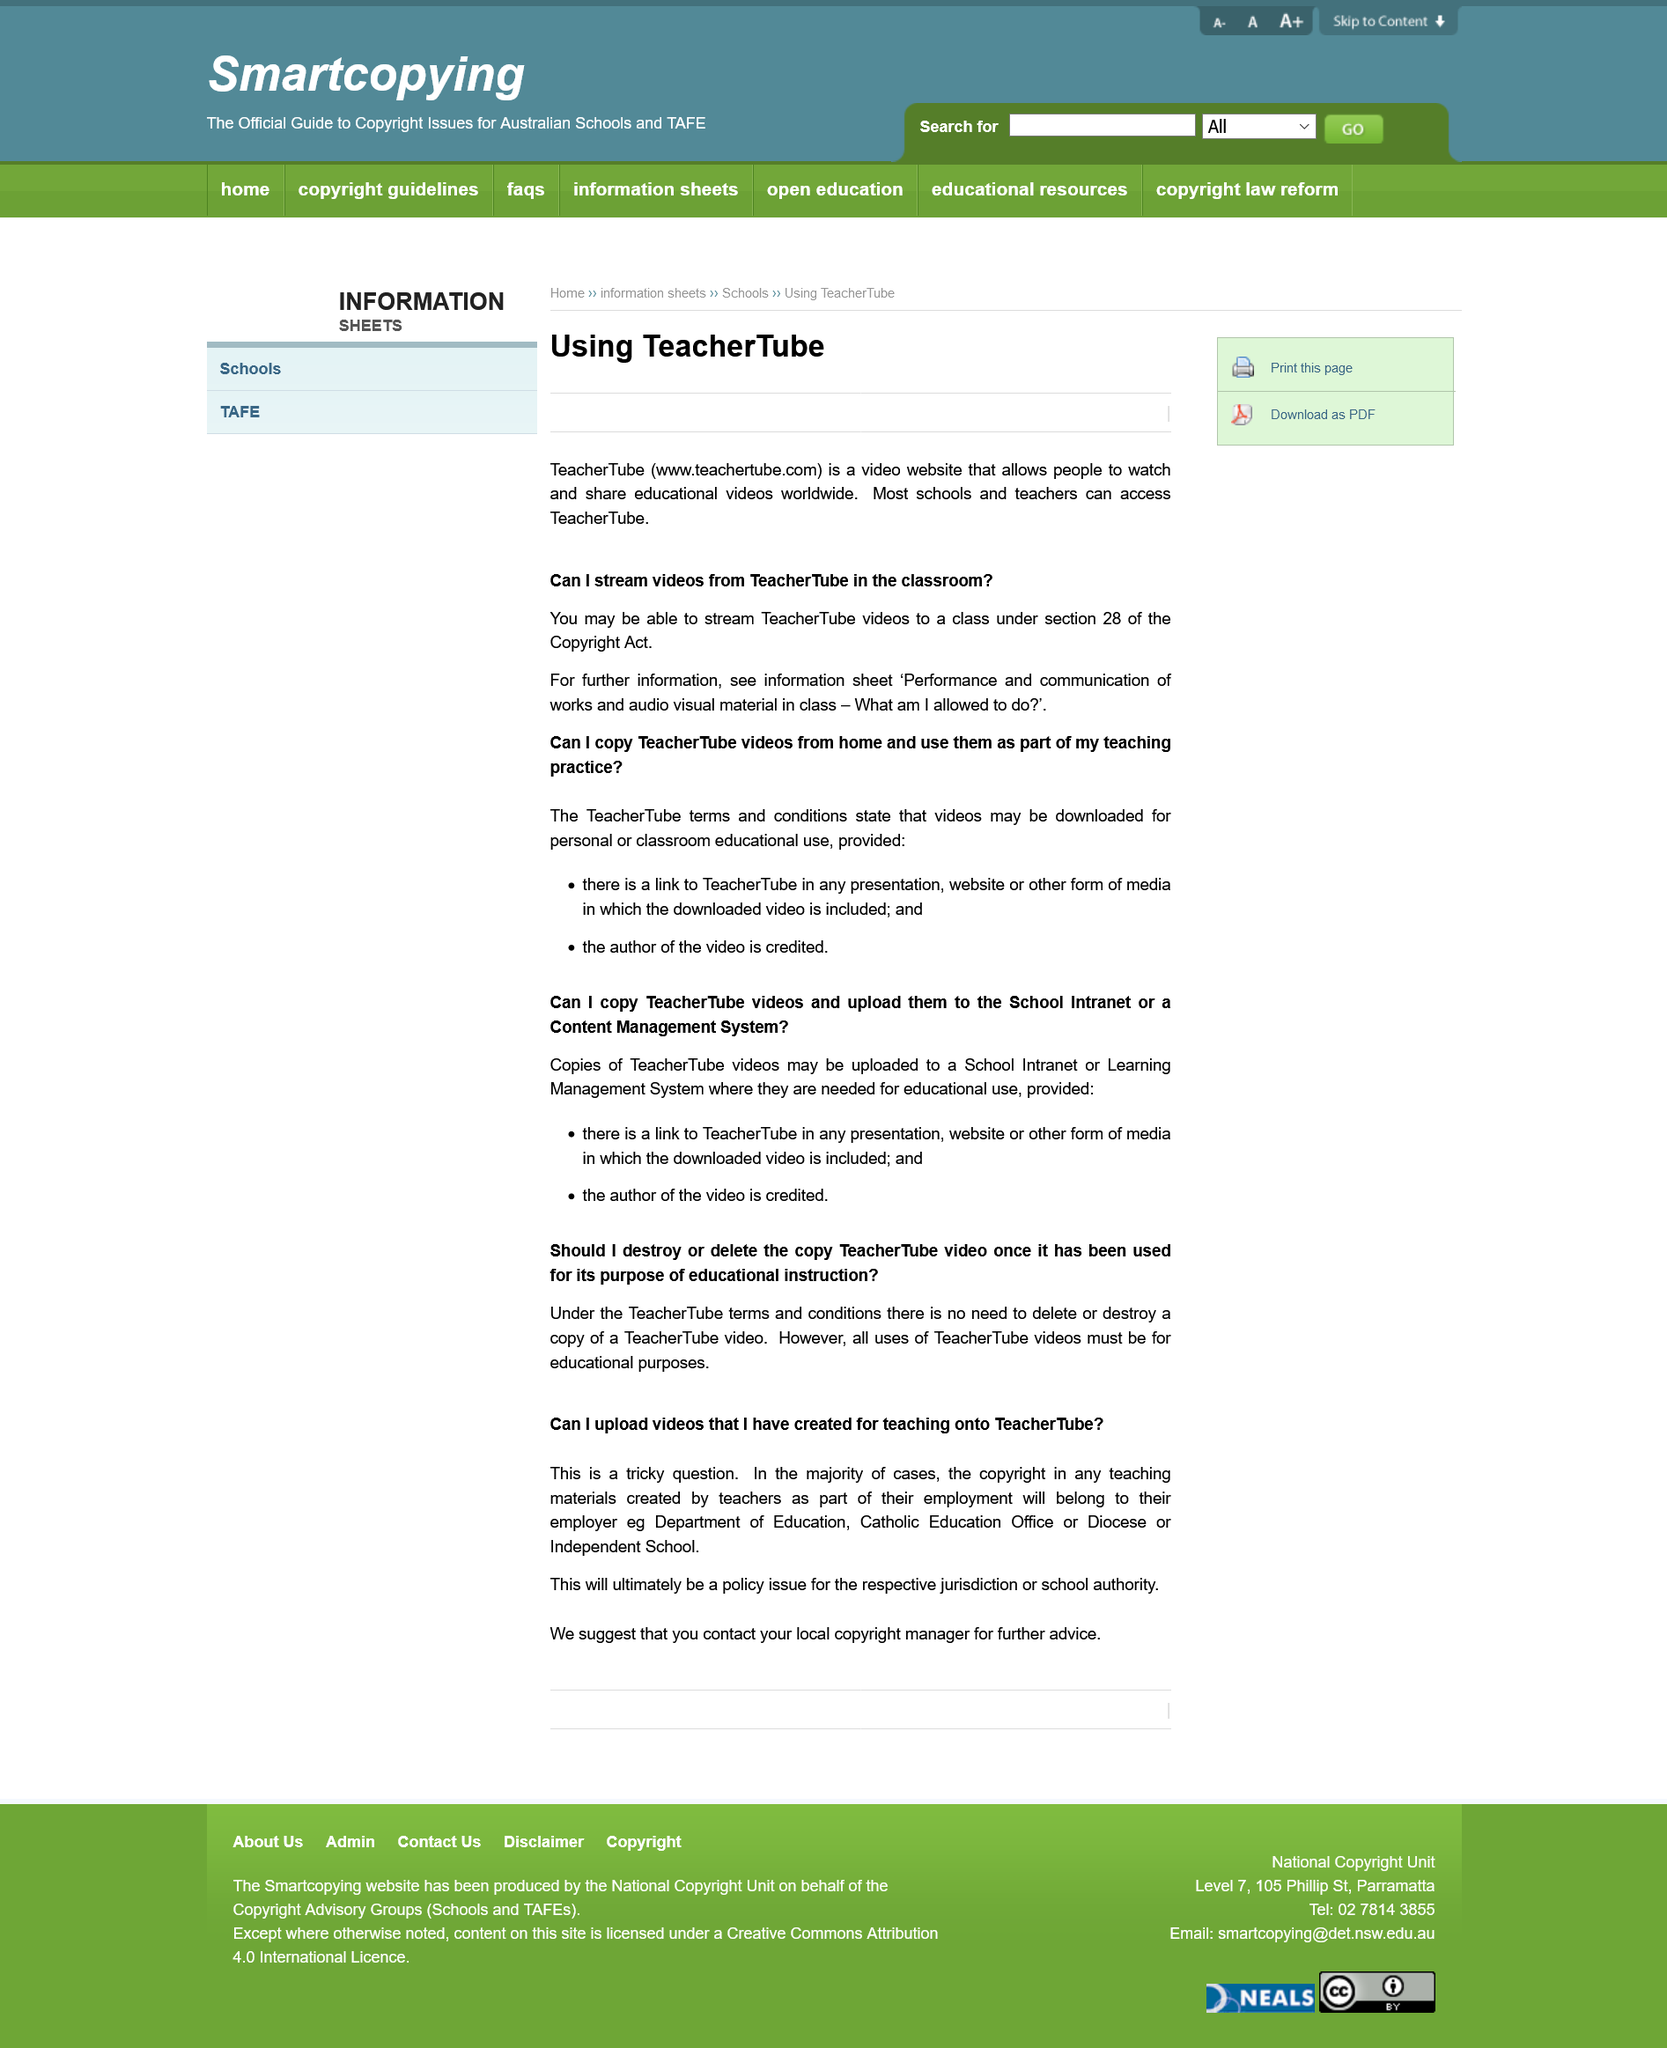Outline some significant characteristics in this image. TeacherTube videos are exclusively used for educational purposes and cannot be categorized under any other categories. TeacherTube videos should not be deleted once used for their purpose on educational instruction. It is not permissible to upload copies of TeacherTube videos to a School Intranet if the author of the video is not credited. It is necessary to provide a link to TeacherTube when presenting a downloaded video. TeacherTube is a video website that provides access to educational videos for people worldwide to watch and share. 